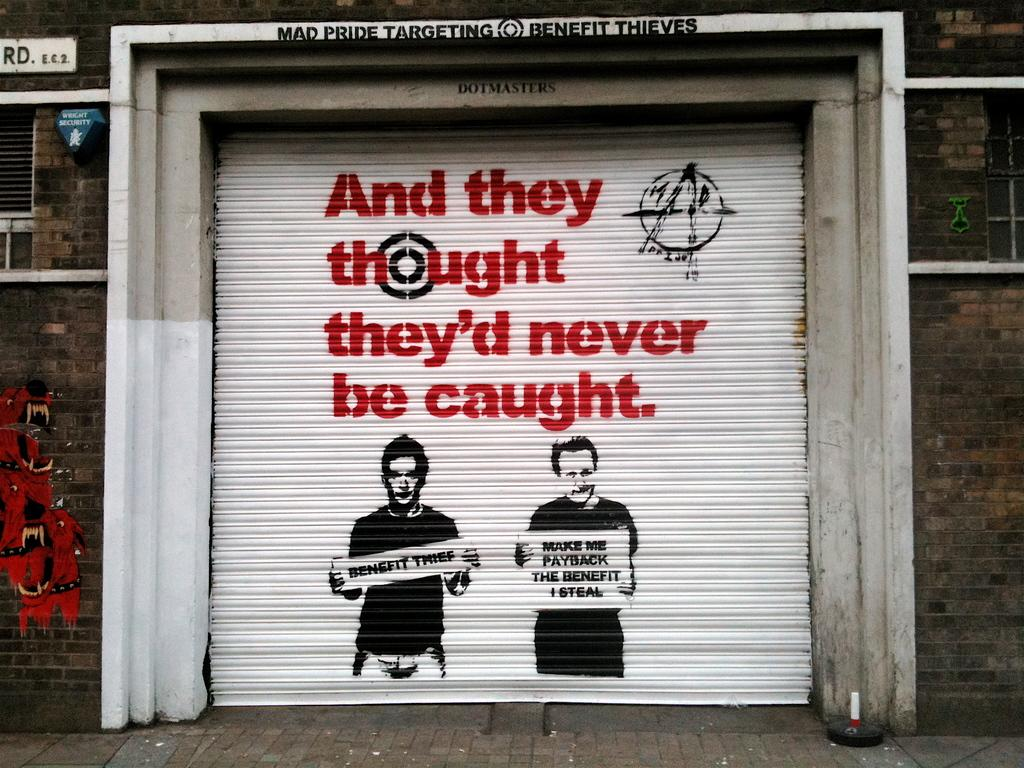What is the main object in the image? There is a rolling shutter in the image. What can be seen on the shutter? Something is written on the shutter, and there is a painting of two people on it. Can you describe the board attached to the wall in the image? Unfortunately, the provided facts do not mention a board attached to a wall in the image. What type of table is visible in the image? There is no table present in the image. Can you tell me how many scissors are depicted in the painting on the shutter? The provided facts do not mention any scissors in the image or the painting on the shutter. 